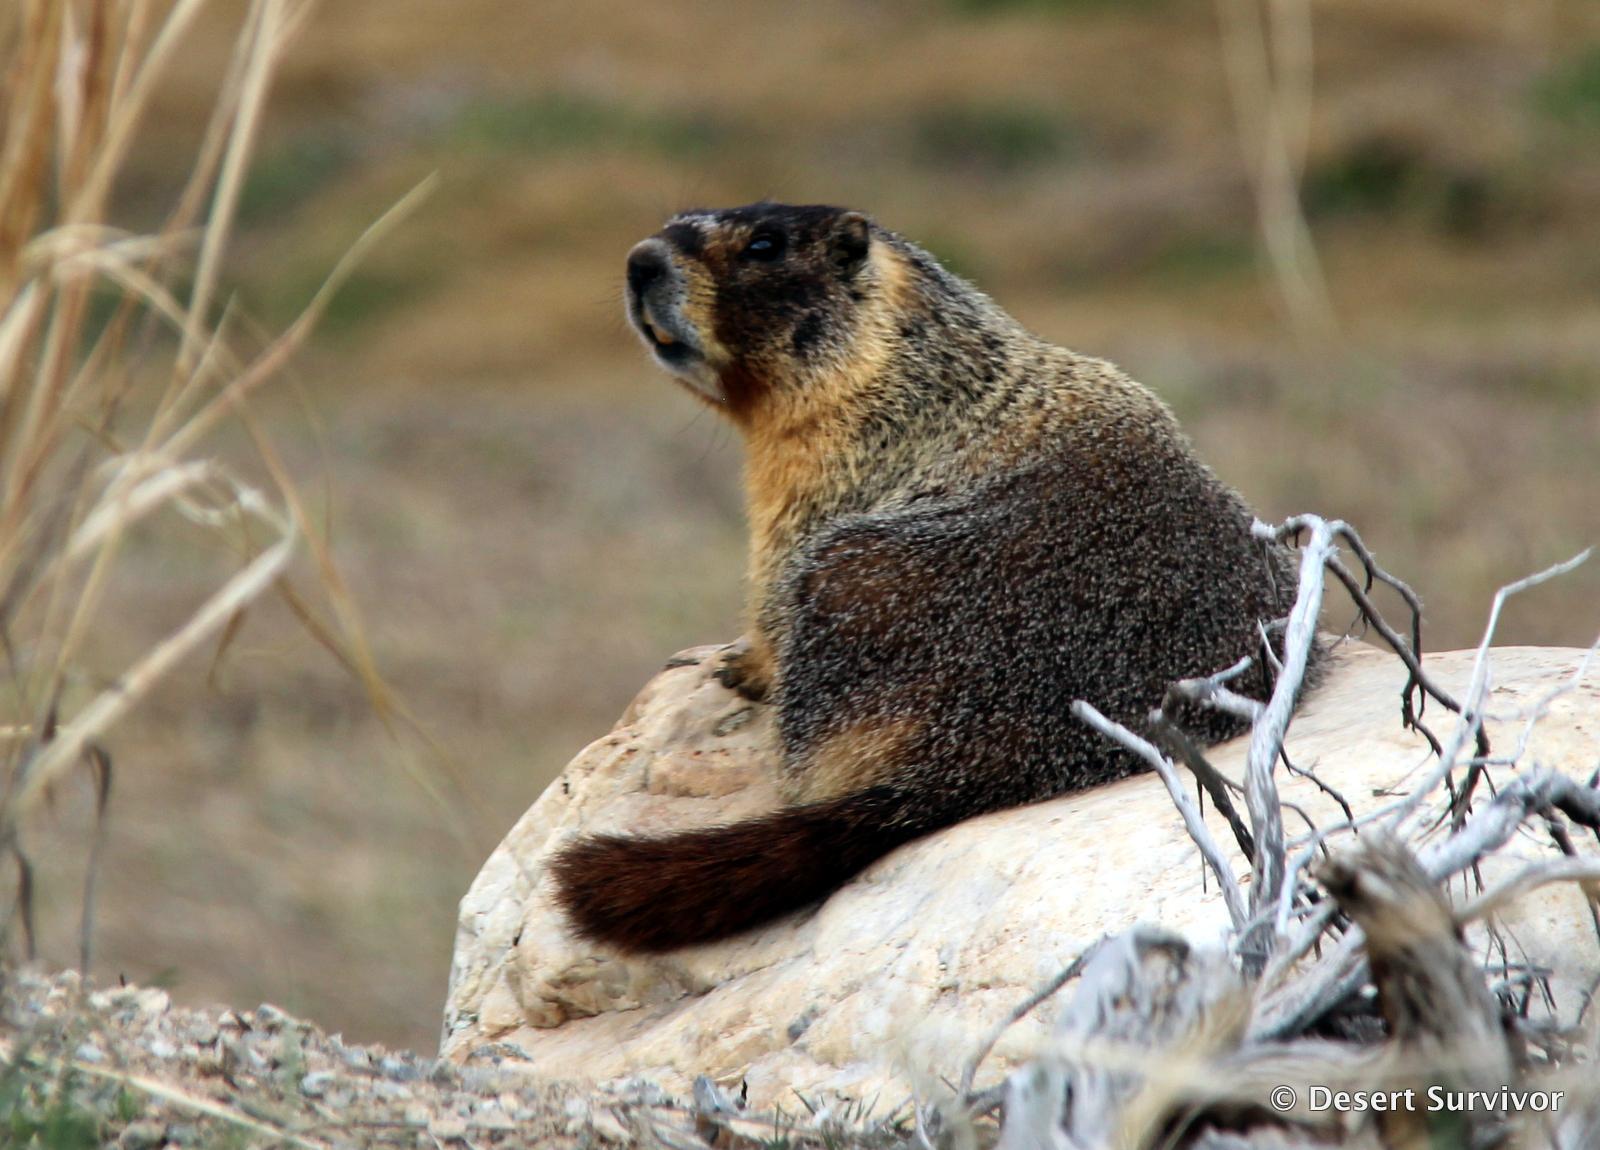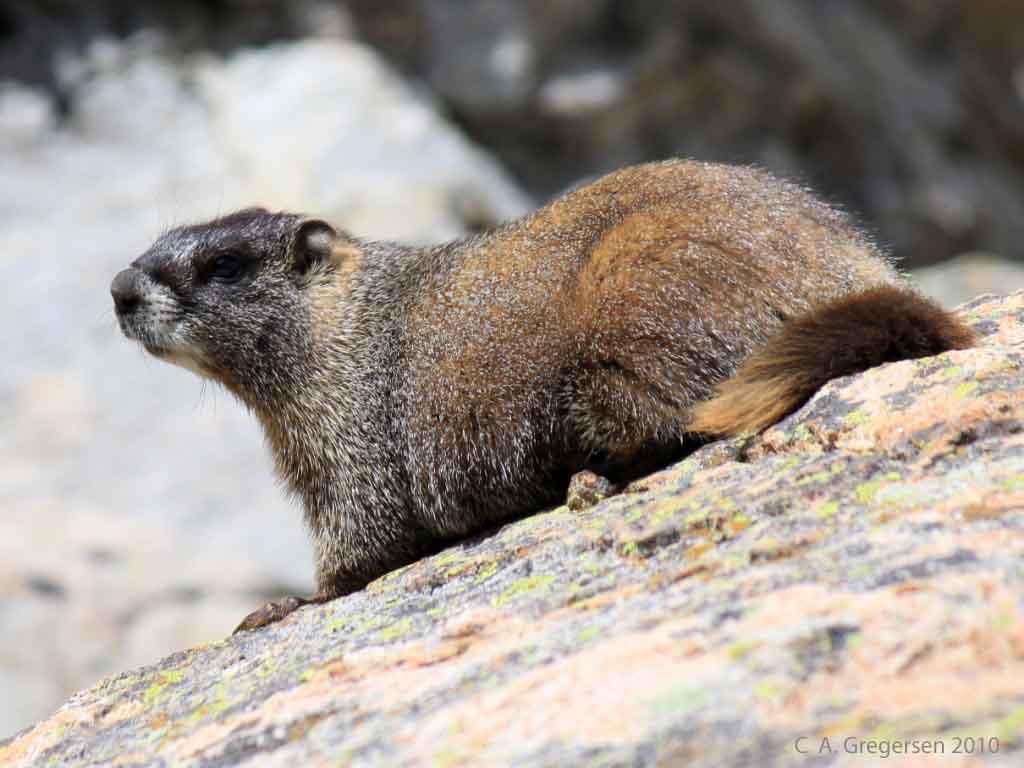The first image is the image on the left, the second image is the image on the right. Analyze the images presented: Is the assertion "the animal on the right image is facing left" valid? Answer yes or no. Yes. 